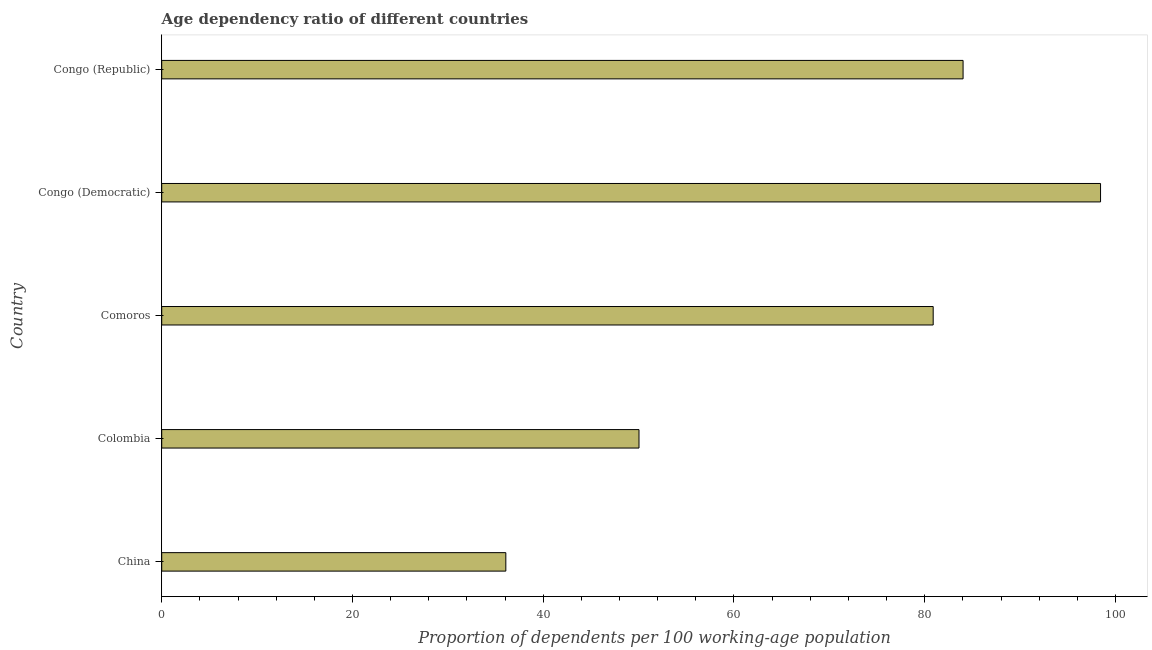What is the title of the graph?
Your answer should be very brief. Age dependency ratio of different countries. What is the label or title of the X-axis?
Provide a succinct answer. Proportion of dependents per 100 working-age population. What is the age dependency ratio in Congo (Republic)?
Offer a terse response. 84.02. Across all countries, what is the maximum age dependency ratio?
Offer a very short reply. 98.44. Across all countries, what is the minimum age dependency ratio?
Ensure brevity in your answer.  36.08. In which country was the age dependency ratio maximum?
Keep it short and to the point. Congo (Democratic). In which country was the age dependency ratio minimum?
Ensure brevity in your answer.  China. What is the sum of the age dependency ratio?
Offer a terse response. 349.47. What is the difference between the age dependency ratio in Colombia and Comoros?
Make the answer very short. -30.84. What is the average age dependency ratio per country?
Offer a terse response. 69.89. What is the median age dependency ratio?
Your response must be concise. 80.89. What is the ratio of the age dependency ratio in Comoros to that in Congo (Democratic)?
Your answer should be compact. 0.82. Is the age dependency ratio in Colombia less than that in Congo (Democratic)?
Your answer should be very brief. Yes. What is the difference between the highest and the second highest age dependency ratio?
Keep it short and to the point. 14.41. What is the difference between the highest and the lowest age dependency ratio?
Offer a terse response. 62.36. How many bars are there?
Keep it short and to the point. 5. Are all the bars in the graph horizontal?
Ensure brevity in your answer.  Yes. What is the difference between two consecutive major ticks on the X-axis?
Offer a very short reply. 20. Are the values on the major ticks of X-axis written in scientific E-notation?
Make the answer very short. No. What is the Proportion of dependents per 100 working-age population of China?
Keep it short and to the point. 36.08. What is the Proportion of dependents per 100 working-age population in Colombia?
Keep it short and to the point. 50.04. What is the Proportion of dependents per 100 working-age population in Comoros?
Give a very brief answer. 80.89. What is the Proportion of dependents per 100 working-age population in Congo (Democratic)?
Ensure brevity in your answer.  98.44. What is the Proportion of dependents per 100 working-age population of Congo (Republic)?
Your response must be concise. 84.02. What is the difference between the Proportion of dependents per 100 working-age population in China and Colombia?
Your answer should be very brief. -13.96. What is the difference between the Proportion of dependents per 100 working-age population in China and Comoros?
Provide a short and direct response. -44.81. What is the difference between the Proportion of dependents per 100 working-age population in China and Congo (Democratic)?
Ensure brevity in your answer.  -62.36. What is the difference between the Proportion of dependents per 100 working-age population in China and Congo (Republic)?
Give a very brief answer. -47.94. What is the difference between the Proportion of dependents per 100 working-age population in Colombia and Comoros?
Offer a very short reply. -30.85. What is the difference between the Proportion of dependents per 100 working-age population in Colombia and Congo (Democratic)?
Provide a succinct answer. -48.39. What is the difference between the Proportion of dependents per 100 working-age population in Colombia and Congo (Republic)?
Your answer should be compact. -33.98. What is the difference between the Proportion of dependents per 100 working-age population in Comoros and Congo (Democratic)?
Your answer should be compact. -17.55. What is the difference between the Proportion of dependents per 100 working-age population in Comoros and Congo (Republic)?
Make the answer very short. -3.13. What is the difference between the Proportion of dependents per 100 working-age population in Congo (Democratic) and Congo (Republic)?
Your response must be concise. 14.41. What is the ratio of the Proportion of dependents per 100 working-age population in China to that in Colombia?
Make the answer very short. 0.72. What is the ratio of the Proportion of dependents per 100 working-age population in China to that in Comoros?
Your answer should be compact. 0.45. What is the ratio of the Proportion of dependents per 100 working-age population in China to that in Congo (Democratic)?
Offer a terse response. 0.37. What is the ratio of the Proportion of dependents per 100 working-age population in China to that in Congo (Republic)?
Provide a succinct answer. 0.43. What is the ratio of the Proportion of dependents per 100 working-age population in Colombia to that in Comoros?
Keep it short and to the point. 0.62. What is the ratio of the Proportion of dependents per 100 working-age population in Colombia to that in Congo (Democratic)?
Your answer should be compact. 0.51. What is the ratio of the Proportion of dependents per 100 working-age population in Colombia to that in Congo (Republic)?
Provide a short and direct response. 0.6. What is the ratio of the Proportion of dependents per 100 working-age population in Comoros to that in Congo (Democratic)?
Offer a terse response. 0.82. What is the ratio of the Proportion of dependents per 100 working-age population in Congo (Democratic) to that in Congo (Republic)?
Give a very brief answer. 1.17. 